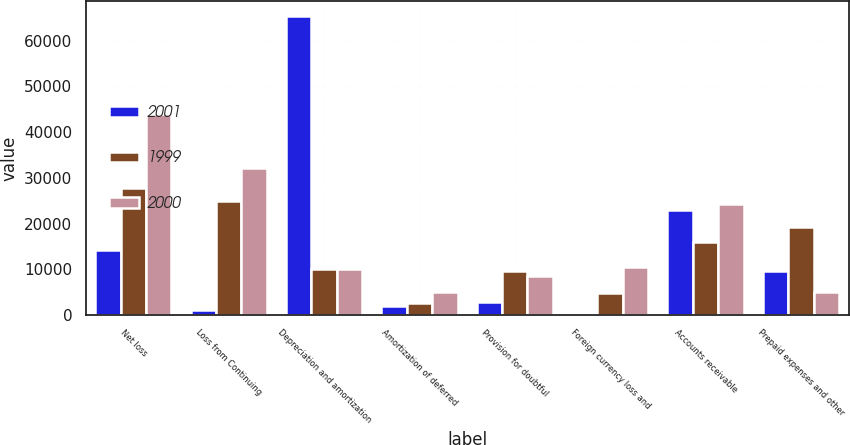<chart> <loc_0><loc_0><loc_500><loc_500><stacked_bar_chart><ecel><fcel>Net loss<fcel>Loss from Continuing<fcel>Depreciation and amortization<fcel>Amortization of deferred<fcel>Provision for doubtful<fcel>Foreign currency loss and<fcel>Accounts receivable<fcel>Prepaid expenses and other<nl><fcel>2001<fcel>14219<fcel>1060<fcel>65422<fcel>1981<fcel>2733<fcel>238<fcel>22996<fcel>9691<nl><fcel>1999<fcel>27825<fcel>24933<fcel>10056.5<fcel>2595<fcel>9714<fcel>4737<fcel>15881<fcel>19332<nl><fcel>2000<fcel>44057<fcel>32238<fcel>10056.5<fcel>4930<fcel>8499<fcel>10399<fcel>24176<fcel>5083<nl></chart> 